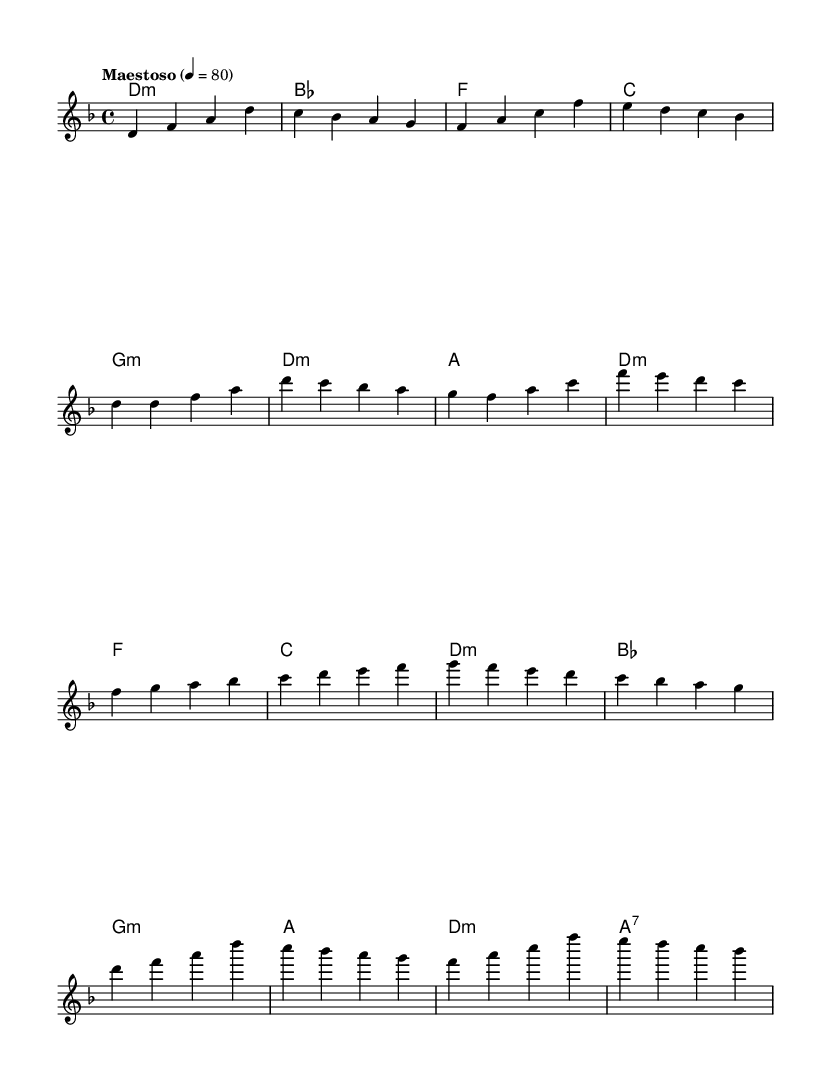What is the key signature of this music? The key signature is D minor, indicated by one flat (B♭). The presence of an A♭ in the chords suggests that it adheres to this key throughout.
Answer: D minor What is the time signature of the piece? The time signature shown is 4/4, which is represented by the four beats per measure in the notation. Each measure contains four quarter note beats.
Answer: 4/4 What is the tempo marking of this music? The tempo marking is "Maestoso," which indicates a stately and dignified character. The specified beats per minute is 80, suggesting a moderate pace.
Answer: Maestoso 80 How many themes are present in the melody? The melody includes two distinct themes labeled as Theme A and Theme B. Each is represented in the sheet music with its own phrasing.
Answer: Two What is the harmonic type of the first chord? The first chord is a D minor chord, indicated by the notation and its context within the key signature. This chord is represented as a minor triad that sets the foundation for the piece.
Answer: D minor What section follows the climax in the melody? The climax is followed by the second theme, which is Theme B. This shift shows a contrast in melody and leads to different emotional dynamics in the piece.
Answer: Theme B How many measures are included in Theme A? Theme A consists of four measures in total, as determined by counting the individual measures represented in the sheet music notation.
Answer: Four 